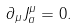Convert formula to latex. <formula><loc_0><loc_0><loc_500><loc_500>\partial _ { \mu } J ^ { \mu } _ { a } = 0 .</formula> 